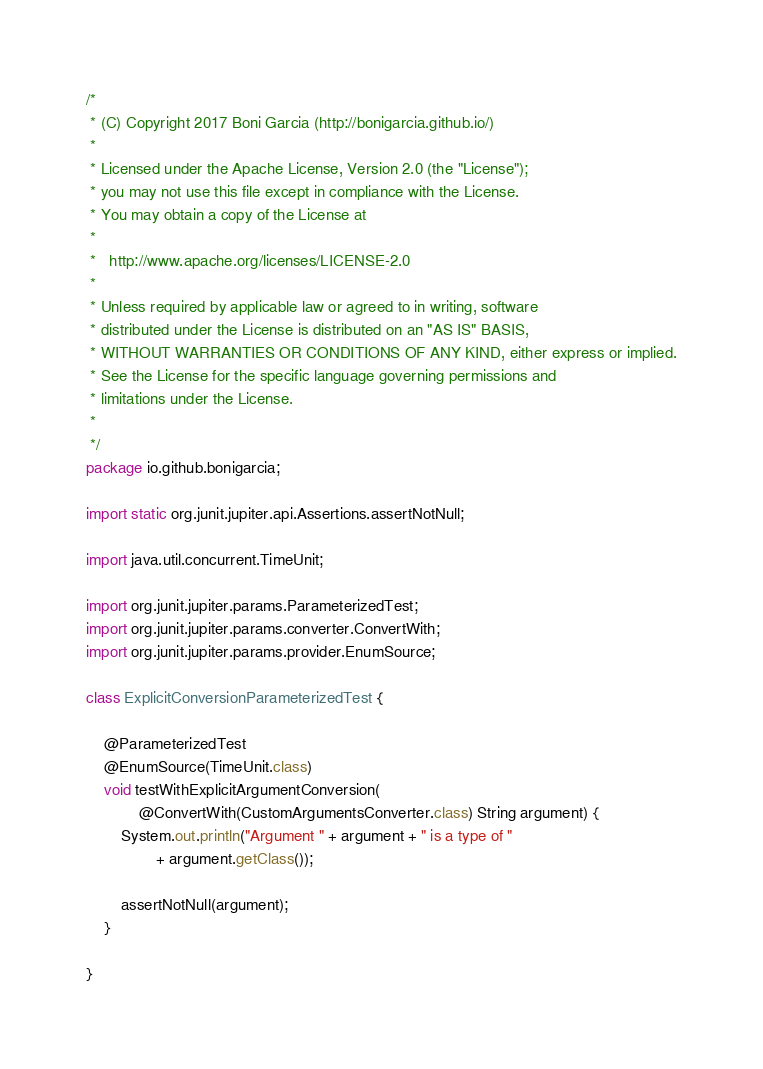Convert code to text. <code><loc_0><loc_0><loc_500><loc_500><_Java_>/*
 * (C) Copyright 2017 Boni Garcia (http://bonigarcia.github.io/)
 *
 * Licensed under the Apache License, Version 2.0 (the "License");
 * you may not use this file except in compliance with the License.
 * You may obtain a copy of the License at
 *
 *   http://www.apache.org/licenses/LICENSE-2.0
 *
 * Unless required by applicable law or agreed to in writing, software
 * distributed under the License is distributed on an "AS IS" BASIS,
 * WITHOUT WARRANTIES OR CONDITIONS OF ANY KIND, either express or implied.
 * See the License for the specific language governing permissions and
 * limitations under the License.
 *
 */
package io.github.bonigarcia;

import static org.junit.jupiter.api.Assertions.assertNotNull;

import java.util.concurrent.TimeUnit;

import org.junit.jupiter.params.ParameterizedTest;
import org.junit.jupiter.params.converter.ConvertWith;
import org.junit.jupiter.params.provider.EnumSource;

class ExplicitConversionParameterizedTest {

    @ParameterizedTest
    @EnumSource(TimeUnit.class)
    void testWithExplicitArgumentConversion(
            @ConvertWith(CustomArgumentsConverter.class) String argument) {
        System.out.println("Argument " + argument + " is a type of "
                + argument.getClass());

        assertNotNull(argument);
    }

}
</code> 